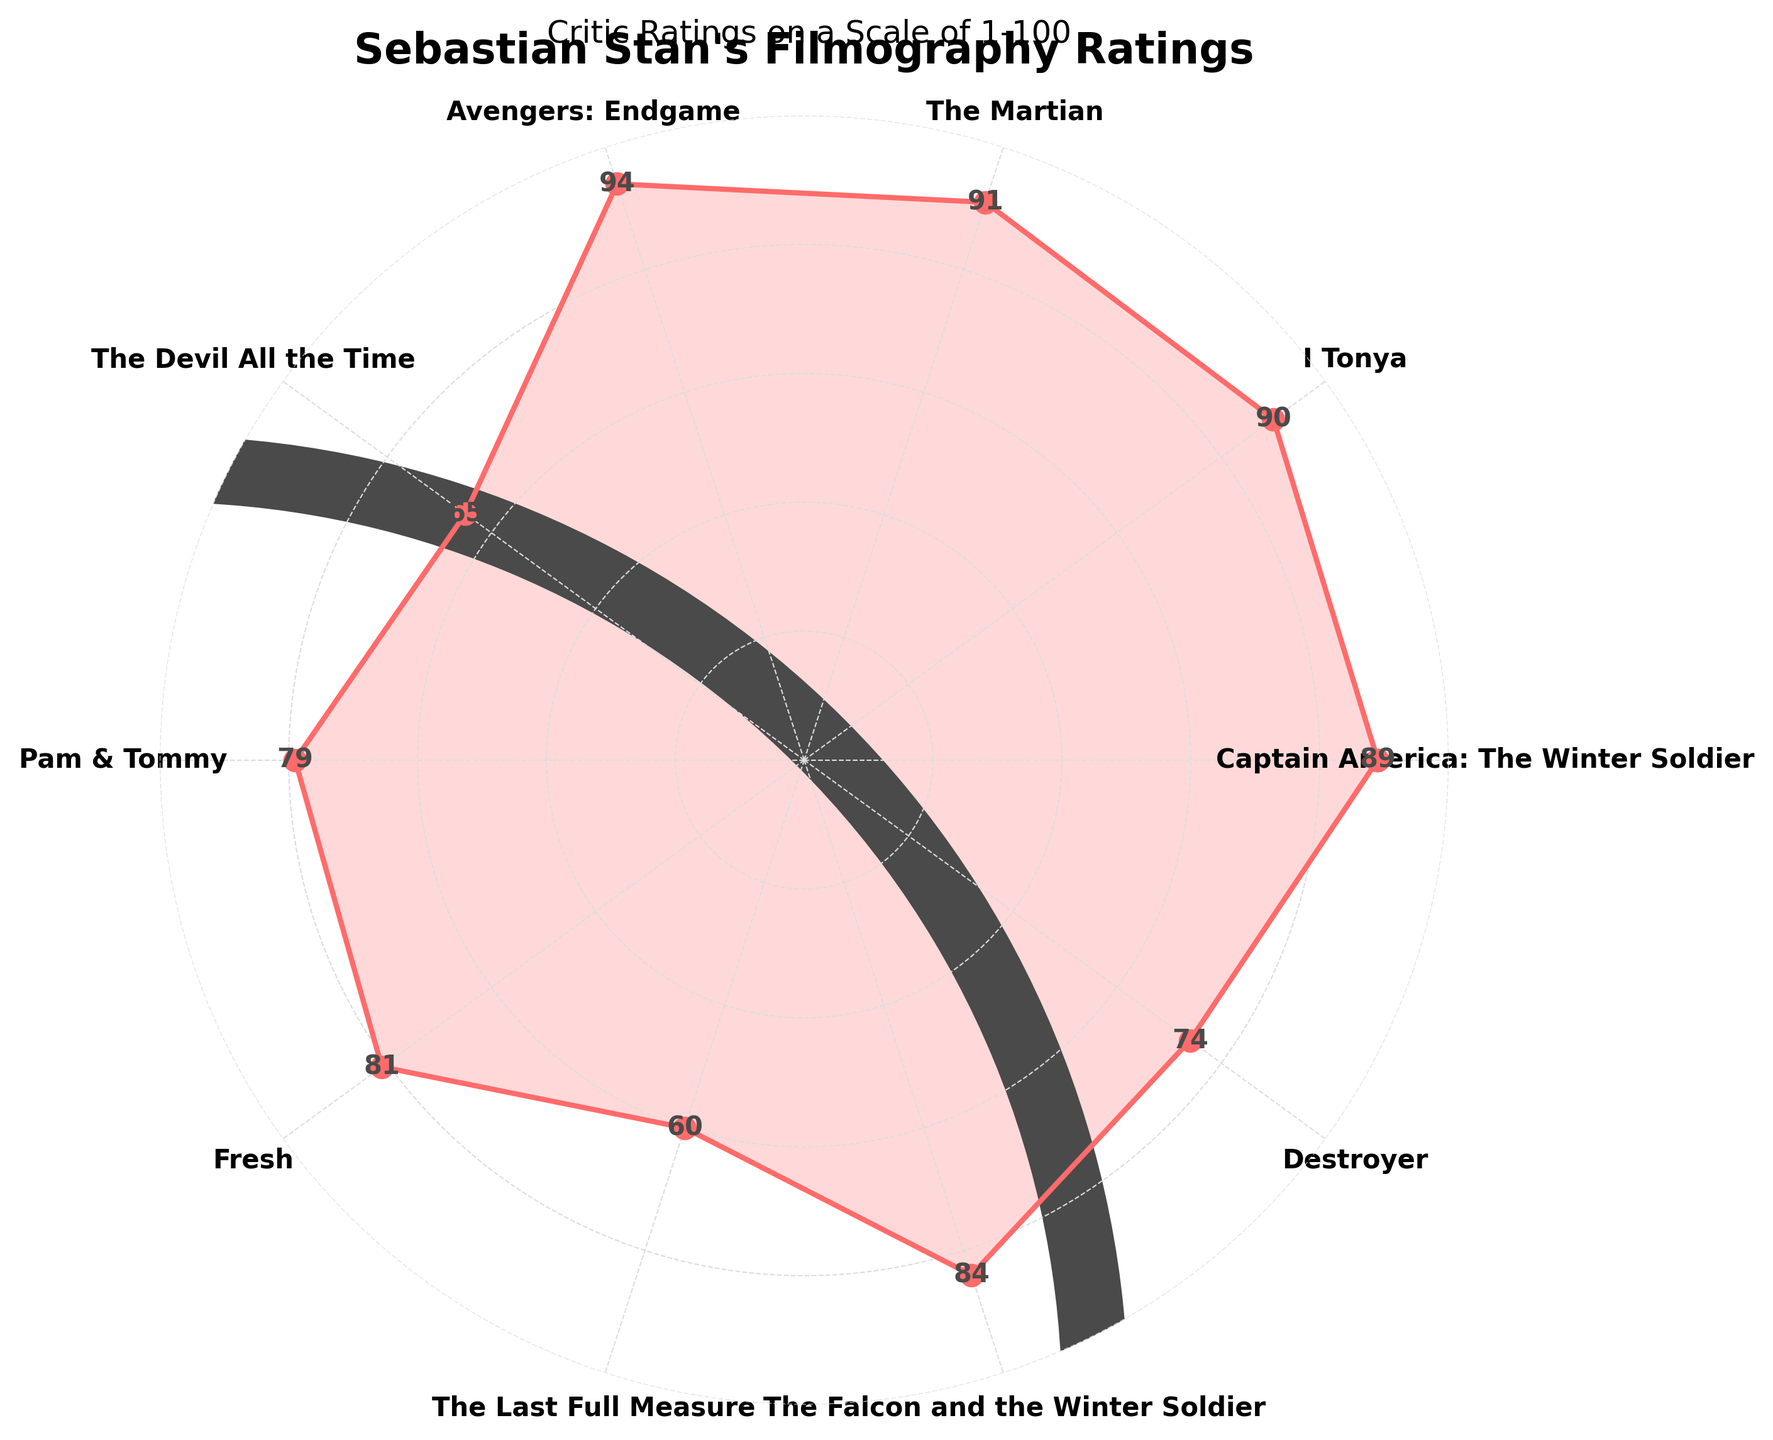What's the highest rated film in Sebastian Stan's filmography according to the gauge chart? The chart lists "Avengers: Endgame" at the highest rating position with a score of 94.
Answer: Avengers: Endgame Which film has the lowest critic rating? By looking at the plot, the lowest point is for "The Last Full Measure" with a rating of 60.
Answer: The Last Full Measure What is the range of critic ratings for the films? The highest rating is 94 and the lowest is 60, thus the range is 94 - 60 = 34.
Answer: 34 Are there more films with ratings above 80 or below 80? "Avengers: Endgame", "The Martian", "I, Tonya", "Captain America: The Winter Soldier", "The Falcon and the Winter Soldier", "Fresh", and "Pam & Tommy" have ratings above 80, totaling 7. "Destroyer", "The Devil All the Time", and "The Last Full Measure" have ratings below 80, totaling 3.
Answer: Above 80 Which two films have the closest rating? "I, Tonya" and "Captain America: The Winter Soldier" have ratings of 90 and 89, respectively, making them the closest in rating.
Answer: I, Tonya and Captain America: The Winter Soldier What is the average rating of all films? Sum all ratings: 89 + 90 + 91 + 94 + 65 + 79 + 81 + 60 + 84 + 74 = 807. Divide by the number of films (10): 807 / 10 = 80.7.
Answer: 80.7 How many films have a rating of 85 or above? "Avengers: Endgame", "The Martian", "I, Tonya", "Captain America: The Winter Soldier", and "The Falcon and the Winter Soldier" are rated 85 or above, totaling 5 films.
Answer: 5 What is the median rating of all films? Arrange the ratings in order: 60, 65, 74, 79, 81, 84, 89, 90, 91, 94. The median is the average of the 5th and 6th values: (81 + 84) / 2 = 82.5.
Answer: 82.5 Which film has the second-lowest rating? "The Devil All the Time" has the second-lowest rating of 65, higher than "The Last Full Measure" and lower than the rest.
Answer: The Devil All the Time 